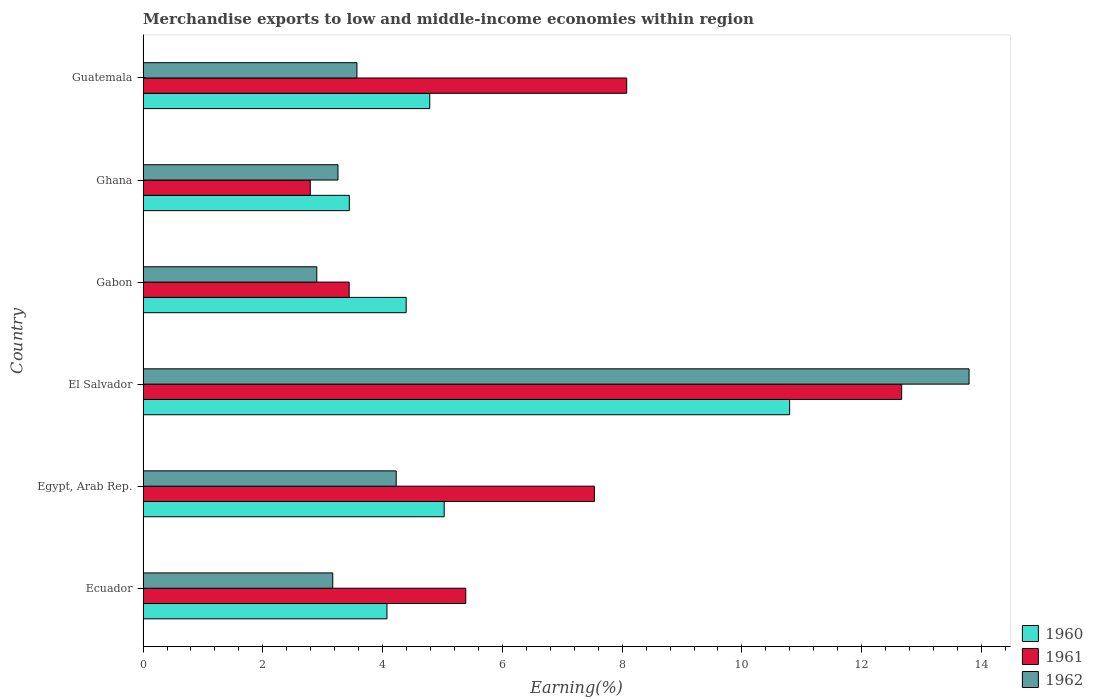How many groups of bars are there?
Provide a short and direct response. 6. How many bars are there on the 2nd tick from the bottom?
Give a very brief answer. 3. What is the label of the 6th group of bars from the top?
Keep it short and to the point. Ecuador. What is the percentage of amount earned from merchandise exports in 1962 in Gabon?
Provide a short and direct response. 2.9. Across all countries, what is the maximum percentage of amount earned from merchandise exports in 1961?
Your answer should be very brief. 12.67. Across all countries, what is the minimum percentage of amount earned from merchandise exports in 1962?
Offer a very short reply. 2.9. In which country was the percentage of amount earned from merchandise exports in 1961 maximum?
Provide a short and direct response. El Salvador. What is the total percentage of amount earned from merchandise exports in 1960 in the graph?
Make the answer very short. 32.52. What is the difference between the percentage of amount earned from merchandise exports in 1961 in Egypt, Arab Rep. and that in Ghana?
Keep it short and to the point. 4.74. What is the difference between the percentage of amount earned from merchandise exports in 1962 in El Salvador and the percentage of amount earned from merchandise exports in 1960 in Guatemala?
Give a very brief answer. 9.01. What is the average percentage of amount earned from merchandise exports in 1961 per country?
Make the answer very short. 6.65. What is the difference between the percentage of amount earned from merchandise exports in 1961 and percentage of amount earned from merchandise exports in 1962 in Guatemala?
Provide a succinct answer. 4.5. What is the ratio of the percentage of amount earned from merchandise exports in 1962 in Ecuador to that in Ghana?
Keep it short and to the point. 0.97. Is the percentage of amount earned from merchandise exports in 1961 in Egypt, Arab Rep. less than that in Gabon?
Provide a short and direct response. No. What is the difference between the highest and the second highest percentage of amount earned from merchandise exports in 1961?
Make the answer very short. 4.59. What is the difference between the highest and the lowest percentage of amount earned from merchandise exports in 1961?
Give a very brief answer. 9.88. In how many countries, is the percentage of amount earned from merchandise exports in 1962 greater than the average percentage of amount earned from merchandise exports in 1962 taken over all countries?
Your response must be concise. 1. Is the sum of the percentage of amount earned from merchandise exports in 1960 in Gabon and Ghana greater than the maximum percentage of amount earned from merchandise exports in 1961 across all countries?
Make the answer very short. No. What does the 2nd bar from the top in Ecuador represents?
Provide a short and direct response. 1961. What does the 3rd bar from the bottom in Gabon represents?
Provide a succinct answer. 1962. How many countries are there in the graph?
Make the answer very short. 6. Are the values on the major ticks of X-axis written in scientific E-notation?
Make the answer very short. No. Where does the legend appear in the graph?
Provide a succinct answer. Bottom right. How many legend labels are there?
Offer a terse response. 3. How are the legend labels stacked?
Keep it short and to the point. Vertical. What is the title of the graph?
Your answer should be very brief. Merchandise exports to low and middle-income economies within region. Does "1960" appear as one of the legend labels in the graph?
Keep it short and to the point. Yes. What is the label or title of the X-axis?
Provide a succinct answer. Earning(%). What is the Earning(%) in 1960 in Ecuador?
Your response must be concise. 4.07. What is the Earning(%) of 1961 in Ecuador?
Give a very brief answer. 5.39. What is the Earning(%) in 1962 in Ecuador?
Make the answer very short. 3.17. What is the Earning(%) in 1960 in Egypt, Arab Rep.?
Your answer should be compact. 5.03. What is the Earning(%) in 1961 in Egypt, Arab Rep.?
Ensure brevity in your answer.  7.54. What is the Earning(%) in 1962 in Egypt, Arab Rep.?
Give a very brief answer. 4.23. What is the Earning(%) of 1960 in El Salvador?
Your response must be concise. 10.8. What is the Earning(%) of 1961 in El Salvador?
Offer a very short reply. 12.67. What is the Earning(%) of 1962 in El Salvador?
Provide a short and direct response. 13.79. What is the Earning(%) of 1960 in Gabon?
Your answer should be compact. 4.39. What is the Earning(%) in 1961 in Gabon?
Provide a short and direct response. 3.44. What is the Earning(%) in 1962 in Gabon?
Your answer should be compact. 2.9. What is the Earning(%) in 1960 in Ghana?
Give a very brief answer. 3.44. What is the Earning(%) in 1961 in Ghana?
Give a very brief answer. 2.79. What is the Earning(%) of 1962 in Ghana?
Provide a succinct answer. 3.25. What is the Earning(%) in 1960 in Guatemala?
Your answer should be compact. 4.79. What is the Earning(%) in 1961 in Guatemala?
Provide a short and direct response. 8.08. What is the Earning(%) of 1962 in Guatemala?
Ensure brevity in your answer.  3.57. Across all countries, what is the maximum Earning(%) of 1960?
Ensure brevity in your answer.  10.8. Across all countries, what is the maximum Earning(%) of 1961?
Offer a very short reply. 12.67. Across all countries, what is the maximum Earning(%) in 1962?
Your response must be concise. 13.79. Across all countries, what is the minimum Earning(%) in 1960?
Your answer should be compact. 3.44. Across all countries, what is the minimum Earning(%) of 1961?
Give a very brief answer. 2.79. Across all countries, what is the minimum Earning(%) of 1962?
Offer a terse response. 2.9. What is the total Earning(%) in 1960 in the graph?
Your response must be concise. 32.52. What is the total Earning(%) in 1961 in the graph?
Provide a succinct answer. 39.9. What is the total Earning(%) in 1962 in the graph?
Offer a very short reply. 30.92. What is the difference between the Earning(%) in 1960 in Ecuador and that in Egypt, Arab Rep.?
Offer a very short reply. -0.96. What is the difference between the Earning(%) in 1961 in Ecuador and that in Egypt, Arab Rep.?
Your answer should be very brief. -2.15. What is the difference between the Earning(%) of 1962 in Ecuador and that in Egypt, Arab Rep.?
Provide a succinct answer. -1.06. What is the difference between the Earning(%) in 1960 in Ecuador and that in El Salvador?
Provide a succinct answer. -6.72. What is the difference between the Earning(%) of 1961 in Ecuador and that in El Salvador?
Your answer should be very brief. -7.28. What is the difference between the Earning(%) of 1962 in Ecuador and that in El Salvador?
Make the answer very short. -10.63. What is the difference between the Earning(%) of 1960 in Ecuador and that in Gabon?
Make the answer very short. -0.32. What is the difference between the Earning(%) of 1961 in Ecuador and that in Gabon?
Ensure brevity in your answer.  1.95. What is the difference between the Earning(%) in 1962 in Ecuador and that in Gabon?
Provide a succinct answer. 0.27. What is the difference between the Earning(%) in 1960 in Ecuador and that in Ghana?
Keep it short and to the point. 0.63. What is the difference between the Earning(%) in 1961 in Ecuador and that in Ghana?
Give a very brief answer. 2.6. What is the difference between the Earning(%) in 1962 in Ecuador and that in Ghana?
Give a very brief answer. -0.09. What is the difference between the Earning(%) in 1960 in Ecuador and that in Guatemala?
Provide a succinct answer. -0.71. What is the difference between the Earning(%) of 1961 in Ecuador and that in Guatemala?
Keep it short and to the point. -2.69. What is the difference between the Earning(%) of 1962 in Ecuador and that in Guatemala?
Keep it short and to the point. -0.4. What is the difference between the Earning(%) in 1960 in Egypt, Arab Rep. and that in El Salvador?
Make the answer very short. -5.77. What is the difference between the Earning(%) in 1961 in Egypt, Arab Rep. and that in El Salvador?
Give a very brief answer. -5.13. What is the difference between the Earning(%) of 1962 in Egypt, Arab Rep. and that in El Salvador?
Your answer should be very brief. -9.57. What is the difference between the Earning(%) in 1960 in Egypt, Arab Rep. and that in Gabon?
Ensure brevity in your answer.  0.63. What is the difference between the Earning(%) of 1961 in Egypt, Arab Rep. and that in Gabon?
Offer a terse response. 4.09. What is the difference between the Earning(%) in 1962 in Egypt, Arab Rep. and that in Gabon?
Provide a succinct answer. 1.33. What is the difference between the Earning(%) in 1960 in Egypt, Arab Rep. and that in Ghana?
Your answer should be very brief. 1.58. What is the difference between the Earning(%) in 1961 in Egypt, Arab Rep. and that in Ghana?
Offer a very short reply. 4.74. What is the difference between the Earning(%) of 1962 in Egypt, Arab Rep. and that in Ghana?
Give a very brief answer. 0.97. What is the difference between the Earning(%) in 1960 in Egypt, Arab Rep. and that in Guatemala?
Ensure brevity in your answer.  0.24. What is the difference between the Earning(%) of 1961 in Egypt, Arab Rep. and that in Guatemala?
Offer a very short reply. -0.54. What is the difference between the Earning(%) in 1962 in Egypt, Arab Rep. and that in Guatemala?
Offer a very short reply. 0.66. What is the difference between the Earning(%) in 1960 in El Salvador and that in Gabon?
Provide a succinct answer. 6.4. What is the difference between the Earning(%) in 1961 in El Salvador and that in Gabon?
Make the answer very short. 9.23. What is the difference between the Earning(%) in 1962 in El Salvador and that in Gabon?
Ensure brevity in your answer.  10.89. What is the difference between the Earning(%) in 1960 in El Salvador and that in Ghana?
Provide a short and direct response. 7.35. What is the difference between the Earning(%) in 1961 in El Salvador and that in Ghana?
Provide a short and direct response. 9.88. What is the difference between the Earning(%) of 1962 in El Salvador and that in Ghana?
Your response must be concise. 10.54. What is the difference between the Earning(%) of 1960 in El Salvador and that in Guatemala?
Your answer should be compact. 6.01. What is the difference between the Earning(%) of 1961 in El Salvador and that in Guatemala?
Your answer should be compact. 4.59. What is the difference between the Earning(%) in 1962 in El Salvador and that in Guatemala?
Offer a very short reply. 10.22. What is the difference between the Earning(%) of 1960 in Gabon and that in Ghana?
Your answer should be compact. 0.95. What is the difference between the Earning(%) of 1961 in Gabon and that in Ghana?
Provide a succinct answer. 0.65. What is the difference between the Earning(%) of 1962 in Gabon and that in Ghana?
Offer a terse response. -0.35. What is the difference between the Earning(%) of 1960 in Gabon and that in Guatemala?
Ensure brevity in your answer.  -0.39. What is the difference between the Earning(%) of 1961 in Gabon and that in Guatemala?
Your answer should be compact. -4.63. What is the difference between the Earning(%) in 1962 in Gabon and that in Guatemala?
Offer a very short reply. -0.67. What is the difference between the Earning(%) in 1960 in Ghana and that in Guatemala?
Keep it short and to the point. -1.34. What is the difference between the Earning(%) in 1961 in Ghana and that in Guatemala?
Provide a short and direct response. -5.28. What is the difference between the Earning(%) in 1962 in Ghana and that in Guatemala?
Ensure brevity in your answer.  -0.32. What is the difference between the Earning(%) of 1960 in Ecuador and the Earning(%) of 1961 in Egypt, Arab Rep.?
Keep it short and to the point. -3.46. What is the difference between the Earning(%) of 1960 in Ecuador and the Earning(%) of 1962 in Egypt, Arab Rep.?
Offer a very short reply. -0.15. What is the difference between the Earning(%) of 1961 in Ecuador and the Earning(%) of 1962 in Egypt, Arab Rep.?
Keep it short and to the point. 1.16. What is the difference between the Earning(%) in 1960 in Ecuador and the Earning(%) in 1961 in El Salvador?
Your answer should be compact. -8.59. What is the difference between the Earning(%) of 1960 in Ecuador and the Earning(%) of 1962 in El Salvador?
Keep it short and to the point. -9.72. What is the difference between the Earning(%) in 1961 in Ecuador and the Earning(%) in 1962 in El Salvador?
Offer a very short reply. -8.4. What is the difference between the Earning(%) in 1960 in Ecuador and the Earning(%) in 1961 in Gabon?
Keep it short and to the point. 0.63. What is the difference between the Earning(%) in 1960 in Ecuador and the Earning(%) in 1962 in Gabon?
Offer a very short reply. 1.17. What is the difference between the Earning(%) in 1961 in Ecuador and the Earning(%) in 1962 in Gabon?
Your answer should be compact. 2.49. What is the difference between the Earning(%) of 1960 in Ecuador and the Earning(%) of 1961 in Ghana?
Your answer should be very brief. 1.28. What is the difference between the Earning(%) in 1960 in Ecuador and the Earning(%) in 1962 in Ghana?
Offer a very short reply. 0.82. What is the difference between the Earning(%) in 1961 in Ecuador and the Earning(%) in 1962 in Ghana?
Keep it short and to the point. 2.13. What is the difference between the Earning(%) of 1960 in Ecuador and the Earning(%) of 1961 in Guatemala?
Make the answer very short. -4. What is the difference between the Earning(%) of 1960 in Ecuador and the Earning(%) of 1962 in Guatemala?
Offer a terse response. 0.5. What is the difference between the Earning(%) of 1961 in Ecuador and the Earning(%) of 1962 in Guatemala?
Your response must be concise. 1.82. What is the difference between the Earning(%) in 1960 in Egypt, Arab Rep. and the Earning(%) in 1961 in El Salvador?
Offer a very short reply. -7.64. What is the difference between the Earning(%) in 1960 in Egypt, Arab Rep. and the Earning(%) in 1962 in El Salvador?
Ensure brevity in your answer.  -8.76. What is the difference between the Earning(%) in 1961 in Egypt, Arab Rep. and the Earning(%) in 1962 in El Salvador?
Give a very brief answer. -6.26. What is the difference between the Earning(%) in 1960 in Egypt, Arab Rep. and the Earning(%) in 1961 in Gabon?
Ensure brevity in your answer.  1.59. What is the difference between the Earning(%) of 1960 in Egypt, Arab Rep. and the Earning(%) of 1962 in Gabon?
Make the answer very short. 2.13. What is the difference between the Earning(%) of 1961 in Egypt, Arab Rep. and the Earning(%) of 1962 in Gabon?
Keep it short and to the point. 4.64. What is the difference between the Earning(%) of 1960 in Egypt, Arab Rep. and the Earning(%) of 1961 in Ghana?
Keep it short and to the point. 2.24. What is the difference between the Earning(%) in 1960 in Egypt, Arab Rep. and the Earning(%) in 1962 in Ghana?
Provide a short and direct response. 1.77. What is the difference between the Earning(%) in 1961 in Egypt, Arab Rep. and the Earning(%) in 1962 in Ghana?
Give a very brief answer. 4.28. What is the difference between the Earning(%) in 1960 in Egypt, Arab Rep. and the Earning(%) in 1961 in Guatemala?
Make the answer very short. -3.05. What is the difference between the Earning(%) of 1960 in Egypt, Arab Rep. and the Earning(%) of 1962 in Guatemala?
Your response must be concise. 1.46. What is the difference between the Earning(%) of 1961 in Egypt, Arab Rep. and the Earning(%) of 1962 in Guatemala?
Ensure brevity in your answer.  3.97. What is the difference between the Earning(%) in 1960 in El Salvador and the Earning(%) in 1961 in Gabon?
Your answer should be compact. 7.35. What is the difference between the Earning(%) of 1960 in El Salvador and the Earning(%) of 1962 in Gabon?
Provide a short and direct response. 7.9. What is the difference between the Earning(%) in 1961 in El Salvador and the Earning(%) in 1962 in Gabon?
Ensure brevity in your answer.  9.77. What is the difference between the Earning(%) of 1960 in El Salvador and the Earning(%) of 1961 in Ghana?
Your answer should be compact. 8. What is the difference between the Earning(%) of 1960 in El Salvador and the Earning(%) of 1962 in Ghana?
Keep it short and to the point. 7.54. What is the difference between the Earning(%) of 1961 in El Salvador and the Earning(%) of 1962 in Ghana?
Your answer should be compact. 9.41. What is the difference between the Earning(%) in 1960 in El Salvador and the Earning(%) in 1961 in Guatemala?
Provide a short and direct response. 2.72. What is the difference between the Earning(%) in 1960 in El Salvador and the Earning(%) in 1962 in Guatemala?
Your answer should be very brief. 7.23. What is the difference between the Earning(%) in 1961 in El Salvador and the Earning(%) in 1962 in Guatemala?
Give a very brief answer. 9.1. What is the difference between the Earning(%) of 1960 in Gabon and the Earning(%) of 1961 in Ghana?
Your response must be concise. 1.6. What is the difference between the Earning(%) in 1960 in Gabon and the Earning(%) in 1962 in Ghana?
Give a very brief answer. 1.14. What is the difference between the Earning(%) in 1961 in Gabon and the Earning(%) in 1962 in Ghana?
Your answer should be compact. 0.19. What is the difference between the Earning(%) of 1960 in Gabon and the Earning(%) of 1961 in Guatemala?
Provide a succinct answer. -3.68. What is the difference between the Earning(%) of 1960 in Gabon and the Earning(%) of 1962 in Guatemala?
Make the answer very short. 0.82. What is the difference between the Earning(%) in 1961 in Gabon and the Earning(%) in 1962 in Guatemala?
Keep it short and to the point. -0.13. What is the difference between the Earning(%) of 1960 in Ghana and the Earning(%) of 1961 in Guatemala?
Offer a terse response. -4.63. What is the difference between the Earning(%) of 1960 in Ghana and the Earning(%) of 1962 in Guatemala?
Provide a succinct answer. -0.13. What is the difference between the Earning(%) of 1961 in Ghana and the Earning(%) of 1962 in Guatemala?
Ensure brevity in your answer.  -0.78. What is the average Earning(%) of 1960 per country?
Make the answer very short. 5.42. What is the average Earning(%) in 1961 per country?
Ensure brevity in your answer.  6.65. What is the average Earning(%) in 1962 per country?
Your answer should be compact. 5.15. What is the difference between the Earning(%) in 1960 and Earning(%) in 1961 in Ecuador?
Your response must be concise. -1.32. What is the difference between the Earning(%) of 1960 and Earning(%) of 1962 in Ecuador?
Make the answer very short. 0.91. What is the difference between the Earning(%) in 1961 and Earning(%) in 1962 in Ecuador?
Offer a terse response. 2.22. What is the difference between the Earning(%) of 1960 and Earning(%) of 1961 in Egypt, Arab Rep.?
Provide a succinct answer. -2.51. What is the difference between the Earning(%) in 1960 and Earning(%) in 1962 in Egypt, Arab Rep.?
Your response must be concise. 0.8. What is the difference between the Earning(%) of 1961 and Earning(%) of 1962 in Egypt, Arab Rep.?
Your response must be concise. 3.31. What is the difference between the Earning(%) in 1960 and Earning(%) in 1961 in El Salvador?
Provide a succinct answer. -1.87. What is the difference between the Earning(%) in 1960 and Earning(%) in 1962 in El Salvador?
Ensure brevity in your answer.  -3. What is the difference between the Earning(%) in 1961 and Earning(%) in 1962 in El Salvador?
Offer a very short reply. -1.13. What is the difference between the Earning(%) in 1960 and Earning(%) in 1961 in Gabon?
Offer a terse response. 0.95. What is the difference between the Earning(%) of 1960 and Earning(%) of 1962 in Gabon?
Provide a succinct answer. 1.49. What is the difference between the Earning(%) of 1961 and Earning(%) of 1962 in Gabon?
Your answer should be very brief. 0.54. What is the difference between the Earning(%) of 1960 and Earning(%) of 1961 in Ghana?
Keep it short and to the point. 0.65. What is the difference between the Earning(%) in 1960 and Earning(%) in 1962 in Ghana?
Your answer should be very brief. 0.19. What is the difference between the Earning(%) of 1961 and Earning(%) of 1962 in Ghana?
Provide a succinct answer. -0.46. What is the difference between the Earning(%) of 1960 and Earning(%) of 1961 in Guatemala?
Give a very brief answer. -3.29. What is the difference between the Earning(%) of 1960 and Earning(%) of 1962 in Guatemala?
Give a very brief answer. 1.22. What is the difference between the Earning(%) of 1961 and Earning(%) of 1962 in Guatemala?
Your answer should be very brief. 4.5. What is the ratio of the Earning(%) of 1960 in Ecuador to that in Egypt, Arab Rep.?
Offer a very short reply. 0.81. What is the ratio of the Earning(%) in 1961 in Ecuador to that in Egypt, Arab Rep.?
Make the answer very short. 0.71. What is the ratio of the Earning(%) in 1962 in Ecuador to that in Egypt, Arab Rep.?
Offer a terse response. 0.75. What is the ratio of the Earning(%) in 1960 in Ecuador to that in El Salvador?
Your response must be concise. 0.38. What is the ratio of the Earning(%) in 1961 in Ecuador to that in El Salvador?
Keep it short and to the point. 0.43. What is the ratio of the Earning(%) in 1962 in Ecuador to that in El Salvador?
Your response must be concise. 0.23. What is the ratio of the Earning(%) in 1960 in Ecuador to that in Gabon?
Provide a short and direct response. 0.93. What is the ratio of the Earning(%) in 1961 in Ecuador to that in Gabon?
Keep it short and to the point. 1.57. What is the ratio of the Earning(%) of 1962 in Ecuador to that in Gabon?
Offer a terse response. 1.09. What is the ratio of the Earning(%) of 1960 in Ecuador to that in Ghana?
Keep it short and to the point. 1.18. What is the ratio of the Earning(%) of 1961 in Ecuador to that in Ghana?
Make the answer very short. 1.93. What is the ratio of the Earning(%) of 1962 in Ecuador to that in Ghana?
Keep it short and to the point. 0.97. What is the ratio of the Earning(%) in 1960 in Ecuador to that in Guatemala?
Give a very brief answer. 0.85. What is the ratio of the Earning(%) of 1961 in Ecuador to that in Guatemala?
Your answer should be very brief. 0.67. What is the ratio of the Earning(%) in 1962 in Ecuador to that in Guatemala?
Your answer should be compact. 0.89. What is the ratio of the Earning(%) in 1960 in Egypt, Arab Rep. to that in El Salvador?
Make the answer very short. 0.47. What is the ratio of the Earning(%) in 1961 in Egypt, Arab Rep. to that in El Salvador?
Make the answer very short. 0.59. What is the ratio of the Earning(%) in 1962 in Egypt, Arab Rep. to that in El Salvador?
Provide a succinct answer. 0.31. What is the ratio of the Earning(%) of 1960 in Egypt, Arab Rep. to that in Gabon?
Your answer should be very brief. 1.14. What is the ratio of the Earning(%) in 1961 in Egypt, Arab Rep. to that in Gabon?
Give a very brief answer. 2.19. What is the ratio of the Earning(%) in 1962 in Egypt, Arab Rep. to that in Gabon?
Your answer should be very brief. 1.46. What is the ratio of the Earning(%) in 1960 in Egypt, Arab Rep. to that in Ghana?
Your answer should be compact. 1.46. What is the ratio of the Earning(%) in 1961 in Egypt, Arab Rep. to that in Ghana?
Provide a succinct answer. 2.7. What is the ratio of the Earning(%) of 1962 in Egypt, Arab Rep. to that in Ghana?
Your response must be concise. 1.3. What is the ratio of the Earning(%) of 1960 in Egypt, Arab Rep. to that in Guatemala?
Keep it short and to the point. 1.05. What is the ratio of the Earning(%) in 1961 in Egypt, Arab Rep. to that in Guatemala?
Offer a terse response. 0.93. What is the ratio of the Earning(%) of 1962 in Egypt, Arab Rep. to that in Guatemala?
Your answer should be very brief. 1.18. What is the ratio of the Earning(%) in 1960 in El Salvador to that in Gabon?
Your answer should be very brief. 2.46. What is the ratio of the Earning(%) in 1961 in El Salvador to that in Gabon?
Ensure brevity in your answer.  3.68. What is the ratio of the Earning(%) of 1962 in El Salvador to that in Gabon?
Offer a terse response. 4.75. What is the ratio of the Earning(%) in 1960 in El Salvador to that in Ghana?
Give a very brief answer. 3.13. What is the ratio of the Earning(%) of 1961 in El Salvador to that in Ghana?
Your answer should be compact. 4.54. What is the ratio of the Earning(%) in 1962 in El Salvador to that in Ghana?
Provide a succinct answer. 4.24. What is the ratio of the Earning(%) in 1960 in El Salvador to that in Guatemala?
Provide a short and direct response. 2.26. What is the ratio of the Earning(%) of 1961 in El Salvador to that in Guatemala?
Offer a very short reply. 1.57. What is the ratio of the Earning(%) of 1962 in El Salvador to that in Guatemala?
Make the answer very short. 3.86. What is the ratio of the Earning(%) in 1960 in Gabon to that in Ghana?
Provide a succinct answer. 1.28. What is the ratio of the Earning(%) of 1961 in Gabon to that in Ghana?
Offer a very short reply. 1.23. What is the ratio of the Earning(%) of 1962 in Gabon to that in Ghana?
Your response must be concise. 0.89. What is the ratio of the Earning(%) in 1960 in Gabon to that in Guatemala?
Your answer should be very brief. 0.92. What is the ratio of the Earning(%) in 1961 in Gabon to that in Guatemala?
Give a very brief answer. 0.43. What is the ratio of the Earning(%) of 1962 in Gabon to that in Guatemala?
Offer a terse response. 0.81. What is the ratio of the Earning(%) in 1960 in Ghana to that in Guatemala?
Ensure brevity in your answer.  0.72. What is the ratio of the Earning(%) of 1961 in Ghana to that in Guatemala?
Keep it short and to the point. 0.35. What is the ratio of the Earning(%) in 1962 in Ghana to that in Guatemala?
Keep it short and to the point. 0.91. What is the difference between the highest and the second highest Earning(%) in 1960?
Keep it short and to the point. 5.77. What is the difference between the highest and the second highest Earning(%) of 1961?
Keep it short and to the point. 4.59. What is the difference between the highest and the second highest Earning(%) of 1962?
Make the answer very short. 9.57. What is the difference between the highest and the lowest Earning(%) in 1960?
Your answer should be compact. 7.35. What is the difference between the highest and the lowest Earning(%) of 1961?
Offer a terse response. 9.88. What is the difference between the highest and the lowest Earning(%) of 1962?
Your answer should be compact. 10.89. 